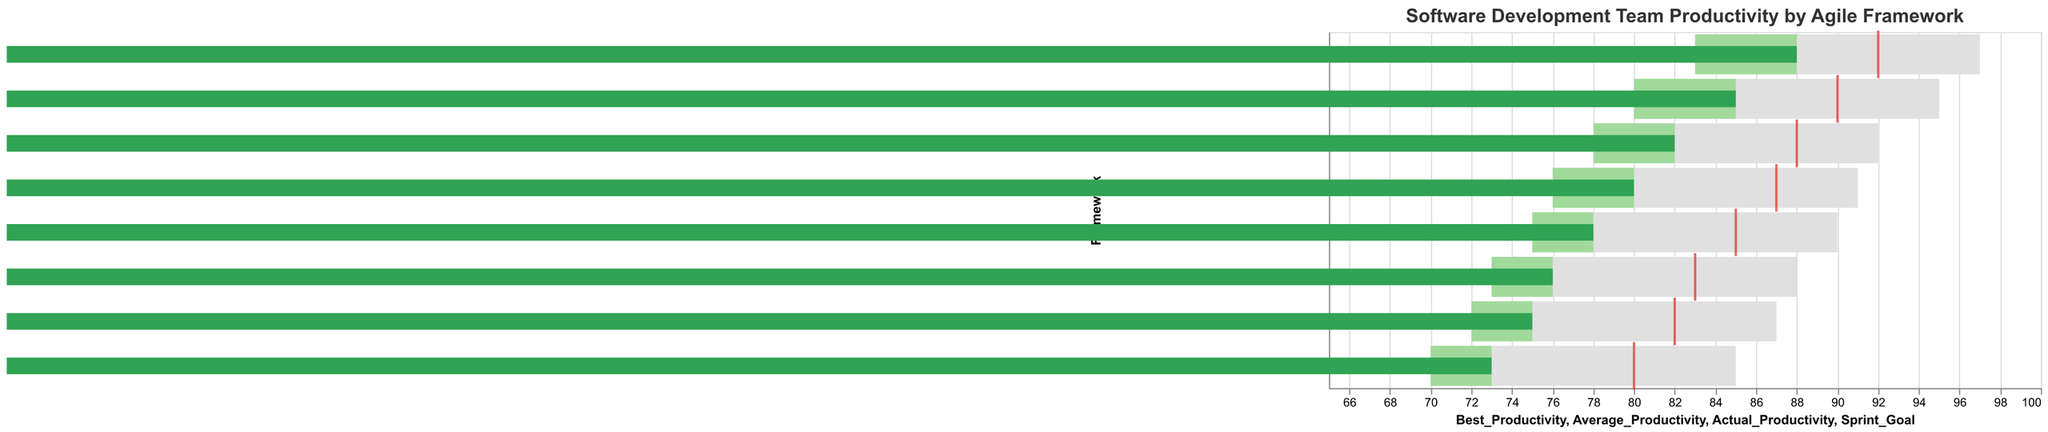How many agile methodologies are compared in the figure? The figure compares eight different agile methodologies as indicated by the "Framework" axis which lists "Scrum," "Kanban," "Extreme Programming (XP)," "Lean Software Development," "Feature-Driven Development (FDD)," "Crystal," "Dynamic Systems Development Method (DSDM)," and "Scaled Agile Framework (SAFe)."
Answer: 8 Which framework has the highest actual productivity, and what is its value? By looking at the "Actual_Productivity" bars, Scaled Agile Framework (SAFe) has the highest actual productivity with a value of 88.
Answer: Scaled Agile Framework (SAFe), 88 What is the best productivity for the "Kanban" framework? The "Best_Productivity" is represented by the light grey bars, and the one corresponding to "Kanban" reaches the value of 90.
Answer: 90 Which framework has the largest difference between its sprint goal and actual productivity? Calculating the differences: "Scrum" (90-85=5), "Kanban" (85-78=7), "Extreme Programming (XP)" (88-82=6), "Lean Software Development" (87-80=7), "Feature-Driven Development (FDD)" (83-76=7), "Crystal" (80-73=7), "Dynamic Systems Development Method (DSDM)" (82-75=7), "Scaled Agile Framework (SAFe)" (92-88=4). The largest difference is for "Kanban," "Lean Software Development," "Feature-Driven Development (FDD)," "Crystal," and "Dynamic Systems Development Method (DSDM)" with a difference of 7.
Answer: Kanban, Lean Software Development, Feature-Driven Development (FDD), Crystal, Dynamic Systems Development Method (DSDM), 7 Which frameworks had actual productivity meeting or exceeding the average productivity? By comparing the "Actual_Productivity" values (dark green bars) to the "Average_Productivity" (middle green bars), "Scrum" (85>=80), "Kanban" (78 >= 75), "Extreme Programming (XP)" (82>=78), "Lean Software Development" (80>=76), and "Scaled Agile Framework (SAFe)" (88>=83), these frameworks met or exceeded their average productivity.
Answer: Scrum, Kanban, Extreme Programming (XP), Lean Software Development, Scaled Agile Framework (SAFe) How does "Scaled Agile Framework (SAFe)" perform against its sprint goal? The "Sprint_Goal" is represented by the red ticks, and for "Scaled Agile Framework (SAFe)," the value is 92. Its "Actual_Productivity" (dark green bar) is 88, which is 4 points less than the sprint goal.
Answer: 4 points less than the sprint goal Which framework has the lowest average productivity, and what is its value? The "Average_Productivity" is represented by the middle green bars, and "Crystal" shows the lowest value with 70.
Answer: Crystal, 70 Compare the best productivity values of "Scrum" and "Kanban." Which one is higher and by how much? The "Best_Productivity" is represented by the light grey bars, "Scrum" has 95, and "Kanban" has 90. Comparing these two, "Scrum" is higher by 5 points.
Answer: Scrum, 5 points higher What is the range of productivity values (from lowest to highest) for the different frameworks? The range is defined as the difference between the highest and lowest actual productivity values across frameworks. The highest is Scaled Agile Framework (SAFe) with 88, and the lowest is Crystal with 73. Thus, the range is 88 - 73 = 15.
Answer: 15 